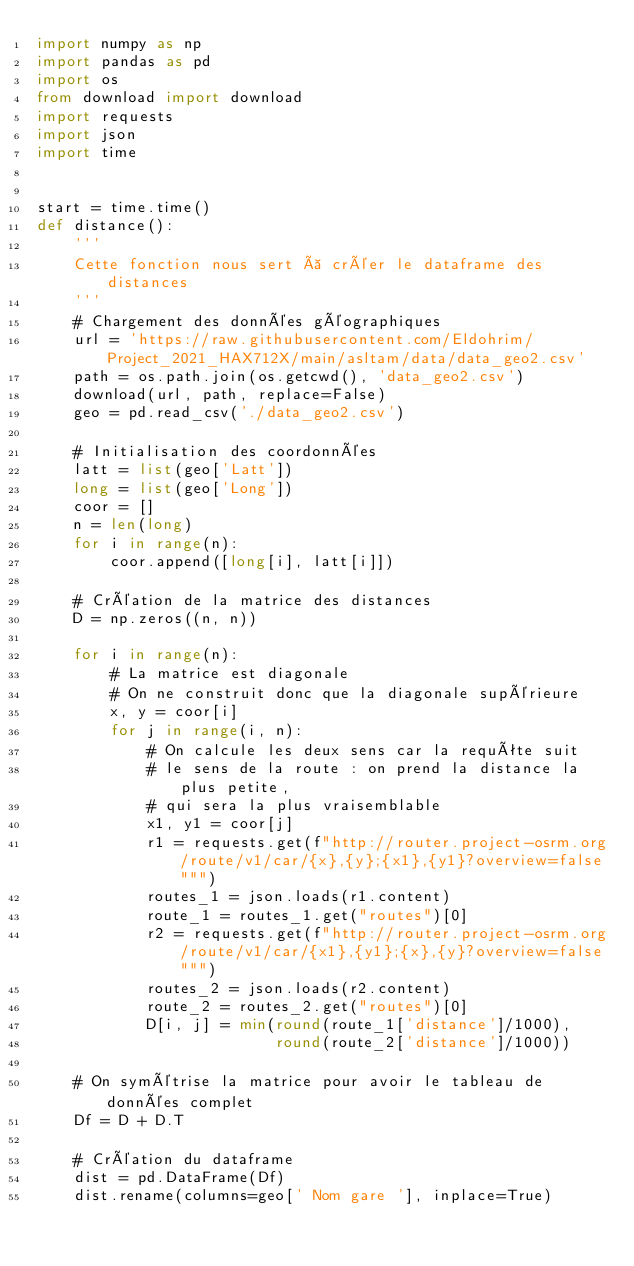<code> <loc_0><loc_0><loc_500><loc_500><_Python_>import numpy as np
import pandas as pd
import os
from download import download
import requests
import json
import time


start = time.time()
def distance():
    '''
    Cette fonction nous sert à créer le dataframe des distances
    '''
    # Chargement des données géographiques
    url = 'https://raw.githubusercontent.com/Eldohrim/Project_2021_HAX712X/main/asltam/data/data_geo2.csv'
    path = os.path.join(os.getcwd(), 'data_geo2.csv')
    download(url, path, replace=False)
    geo = pd.read_csv('./data_geo2.csv')

    # Initialisation des coordonnées
    latt = list(geo['Latt'])
    long = list(geo['Long'])
    coor = []
    n = len(long)
    for i in range(n):
        coor.append([long[i], latt[i]])

    # Création de la matrice des distances
    D = np.zeros((n, n))

    for i in range(n):
        # La matrice est diagonale
        # On ne construit donc que la diagonale supérieure
        x, y = coor[i]
        for j in range(i, n):
            # On calcule les deux sens car la requête suit
            # le sens de la route : on prend la distance la plus petite,
            # qui sera la plus vraisemblable
            x1, y1 = coor[j]
            r1 = requests.get(f"http://router.project-osrm.org/route/v1/car/{x},{y};{x1},{y1}?overview=false""")
            routes_1 = json.loads(r1.content)
            route_1 = routes_1.get("routes")[0]
            r2 = requests.get(f"http://router.project-osrm.org/route/v1/car/{x1},{y1};{x},{y}?overview=false""")
            routes_2 = json.loads(r2.content)
            route_2 = routes_2.get("routes")[0]
            D[i, j] = min(round(route_1['distance']/1000),
                          round(route_2['distance']/1000))

    # On symétrise la matrice pour avoir le tableau de données complet
    Df = D + D.T

    # Création du dataframe
    dist = pd.DataFrame(Df)
    dist.rename(columns=geo[' Nom gare '], inplace=True)</code> 